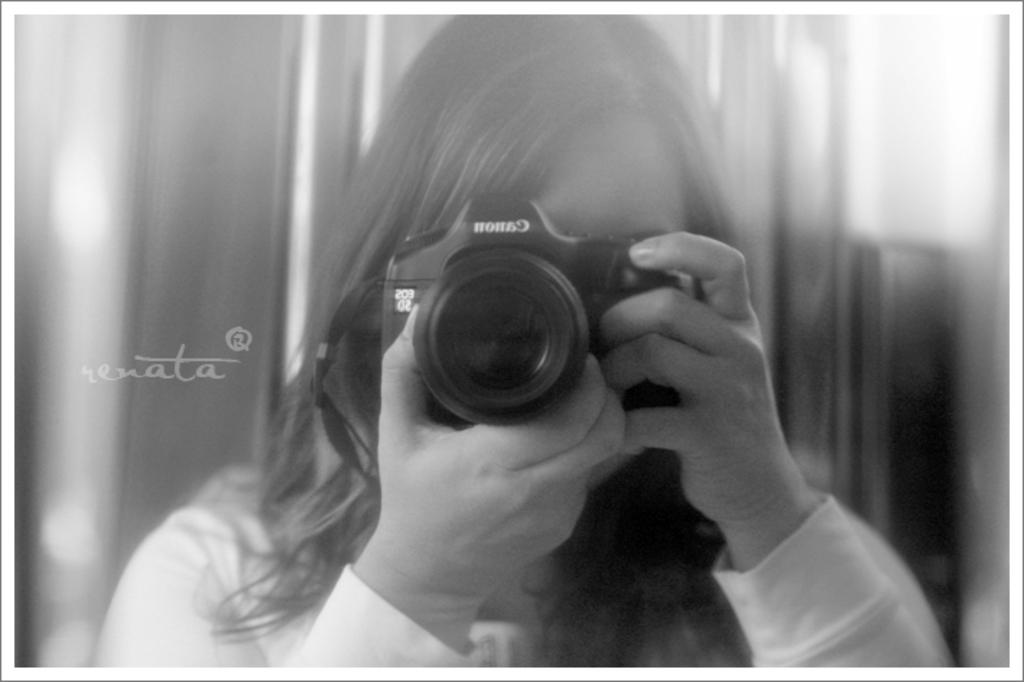What is the color scheme of the image? The image is black and white. Who is present in the picture? There is a woman in the picture. What is the woman holding in the image? The woman is holding a Canon black camera. What can be seen behind the woman in the image? There is a blue background behind the woman. How much attention is the woman giving to the division of the camera in the image? There is no indication in the image that the woman is giving attention to the division of the camera, as the camera is a single object and not divided. 